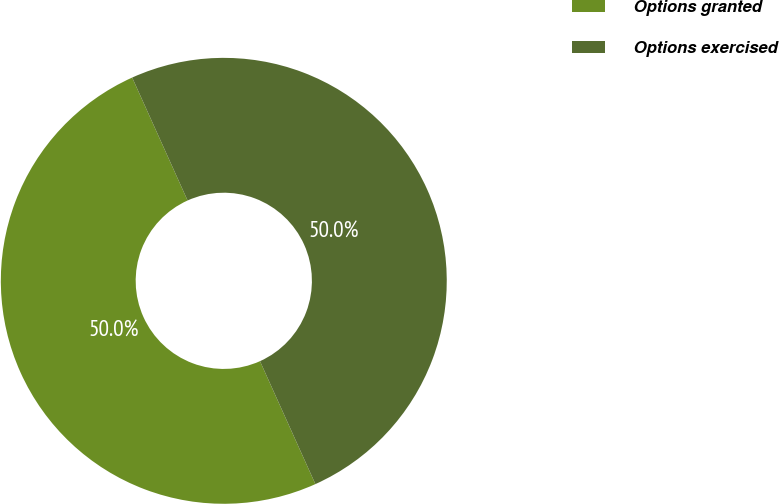Convert chart to OTSL. <chart><loc_0><loc_0><loc_500><loc_500><pie_chart><fcel>Options granted<fcel>Options exercised<nl><fcel>50.0%<fcel>50.0%<nl></chart> 